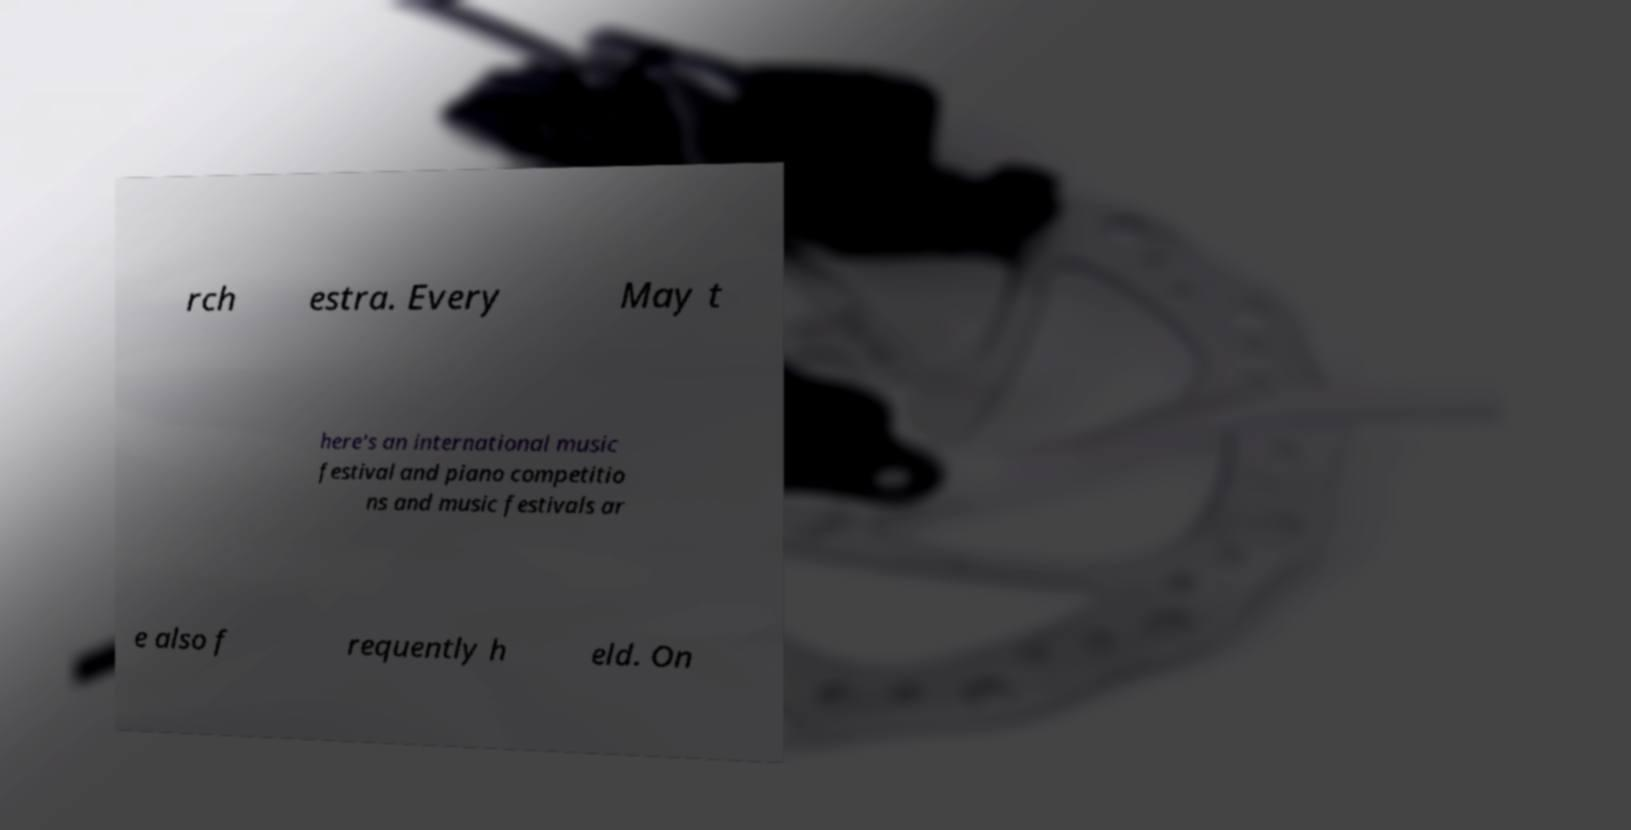For documentation purposes, I need the text within this image transcribed. Could you provide that? rch estra. Every May t here's an international music festival and piano competitio ns and music festivals ar e also f requently h eld. On 